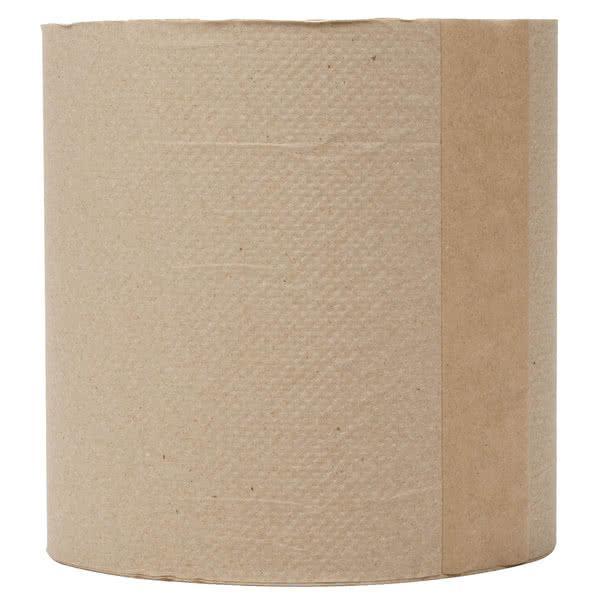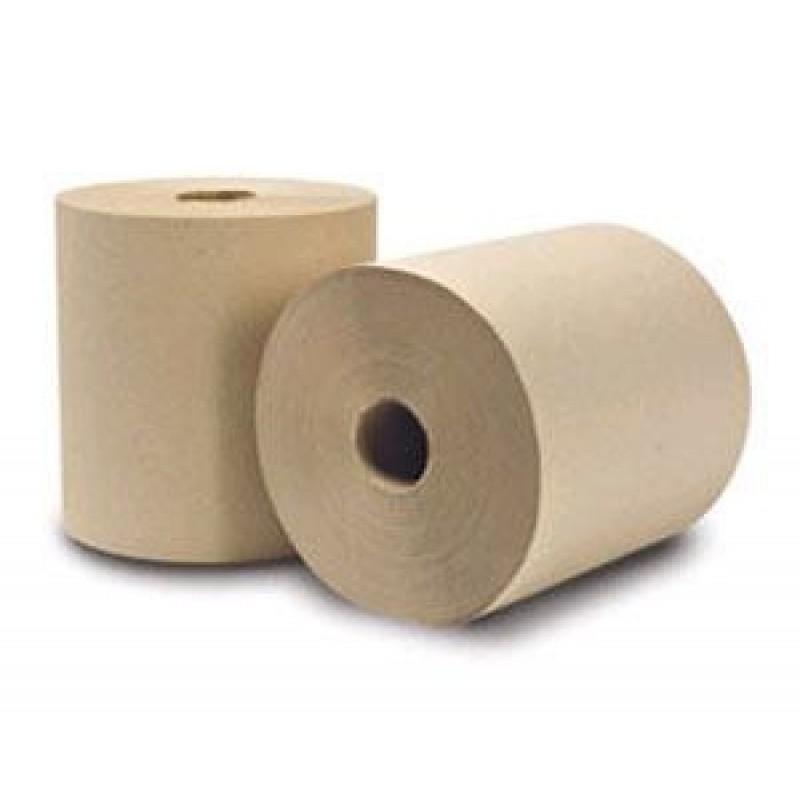The first image is the image on the left, the second image is the image on the right. Evaluate the accuracy of this statement regarding the images: "The roll of paper in the image on the left is partially unrolled". Is it true? Answer yes or no. No. The first image is the image on the left, the second image is the image on the right. Analyze the images presented: Is the assertion "No paper towel rolls have sheets unfurled." valid? Answer yes or no. Yes. 